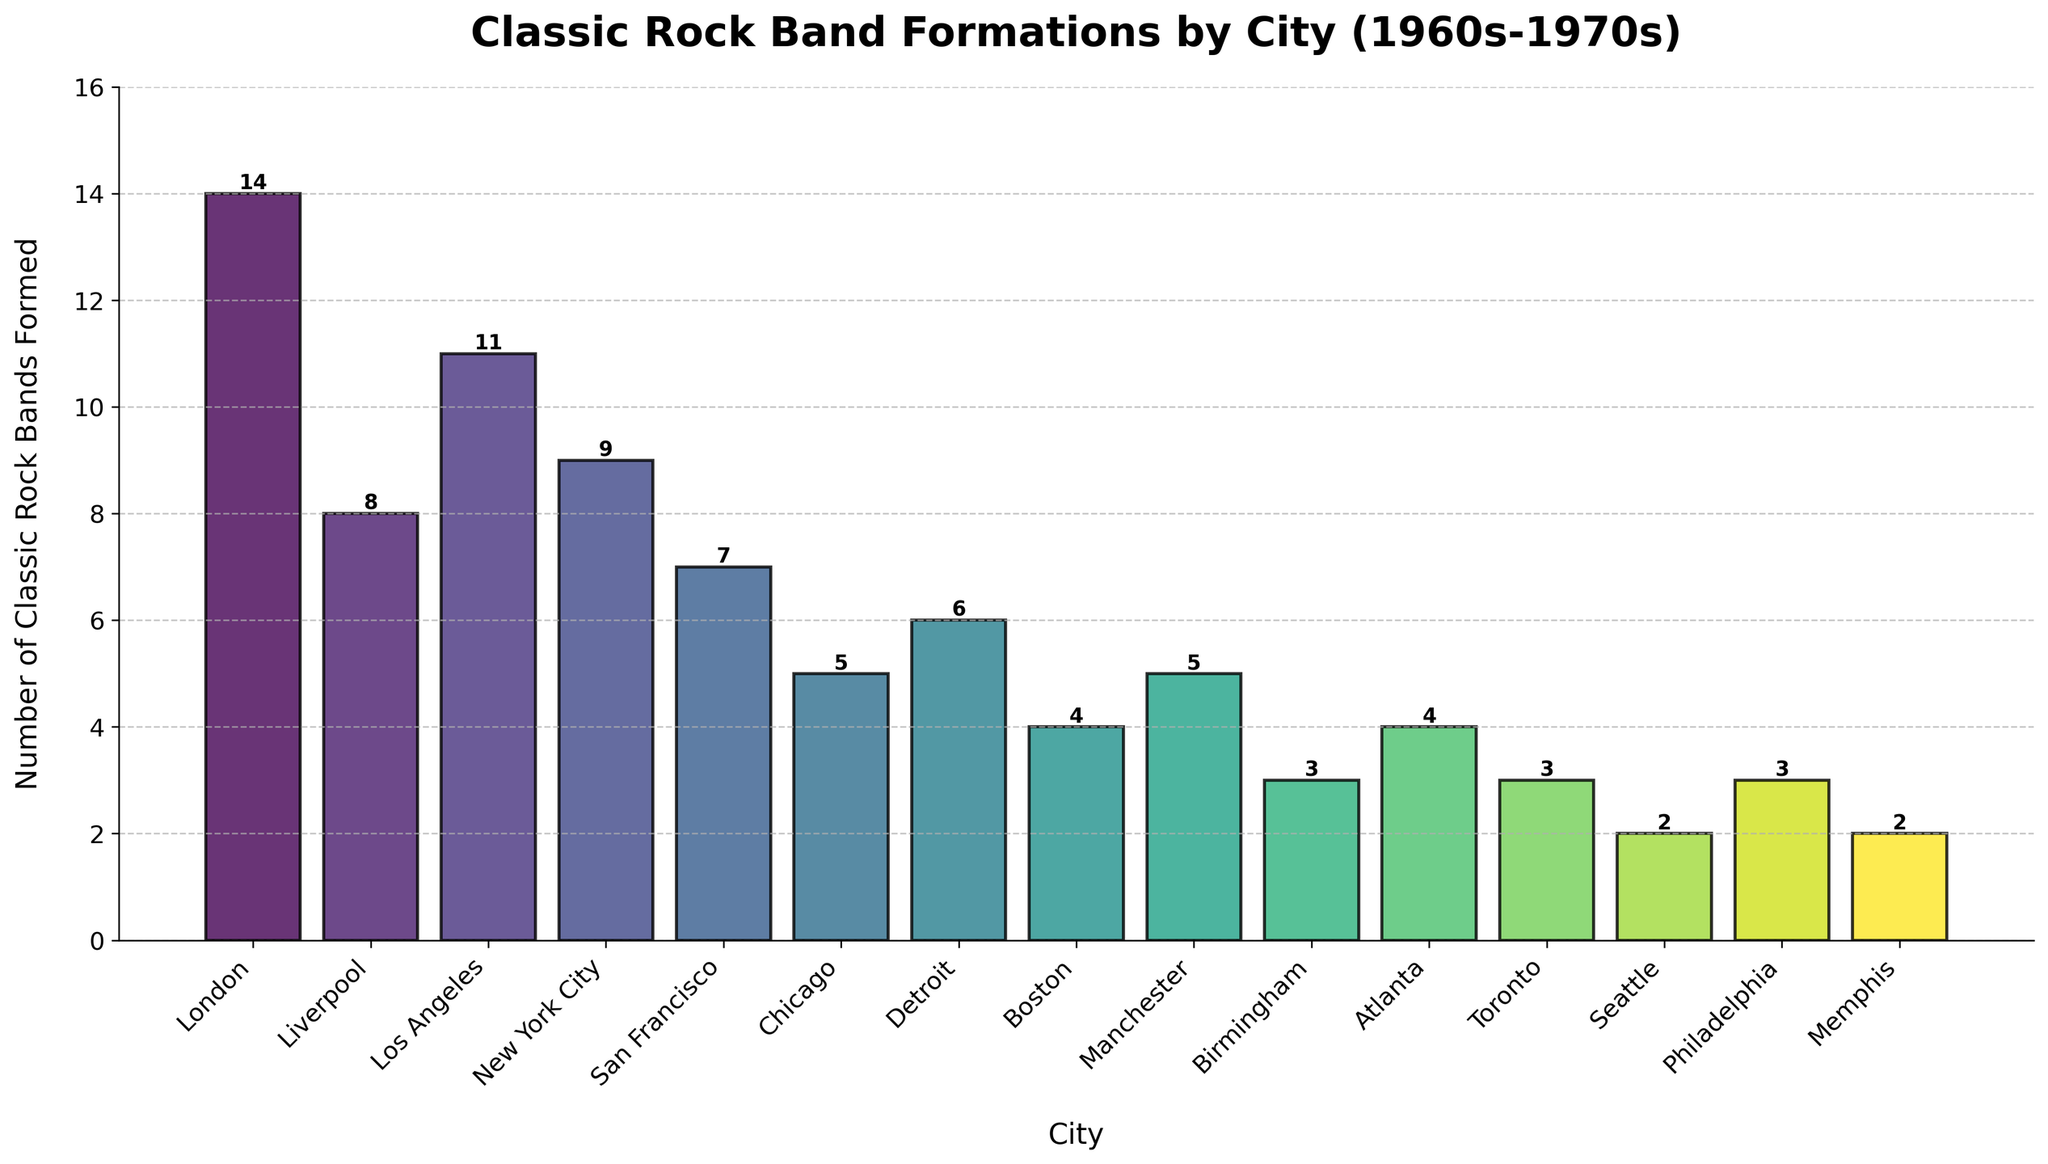Which city formed the highest number of classic rock bands? Among the cities listed in the figure, London has the highest bar, indicating that it formed the highest number of classic rock bands (14 bands).
Answer: London Which two cities together formed the most classic rock bands? The two cities with the highest bars are London (14) and Los Angeles (11). The combined total is 14 + 11 = 25 bands.
Answer: London and Los Angeles How many more classic rock bands were formed in New York City than in Boston? In the figure, New York City has 9 bands, and Boston has 4 bands. The difference is 9 - 4 = 5 bands.
Answer: 5 Which city has a bar color closest to green? The viridis color map transitions through shades of green. The city with a bar color closest to green is most likely Chicago (5 bands) located in the mid-range of the colormap.
Answer: Chicago What are the average number of bands formed in the cities with 4 or more bands? Cities with 4 or more bands: London (14), Liverpool (8), Los Angeles (11), New York City (9), San Francisco (7), Chicago (5), Detroit (6), Boston (4), Manchester (5), Atlanta (4). Sum: 14 + 8 + 11 + 9 + 7 + 5 + 6 + 4 + 5 + 4 = 73 bands. Number of cities = 10. Average = 73/10 = 7.3 bands.
Answer: 7.3 Which city formed fewer classic rock bands, Atlanta or Philadelphia? In the figure, both Atlanta and Philadelphia have bars of equal height, representing 4 and 3 bands respectively.
Answer: Philadelphia How many cities formed exactly 5 classic rock bands? The figure shows three bars that indicate 5 bands each, representing Chicago, Manchester, and one more city.
Answer: 2 What is the total number of classic rock bands formed in all the cities combined? Adding the number of bands formed in all cities: 14 (London) + 8 (Liverpool) + 11 (Los Angeles) + 9 (New York City) + 7 (San Francisco) + 5 (Chicago) + 6 (Detroit) + 4 (Boston) + 5 (Manchester) + 3 (Birmingham) + 4 (Atlanta) + 3 (Toronto) + 2 (Seattle) + 3 (Philadelphia) + 2 (Memphis) = 86.
Answer: 86 Which city has the lowest number of classic rock bands formed and how many? The city with the lowest bar is Seattle and Memphis, each with 2 bands.
Answer: Seattle and Memphis, 2 bands 